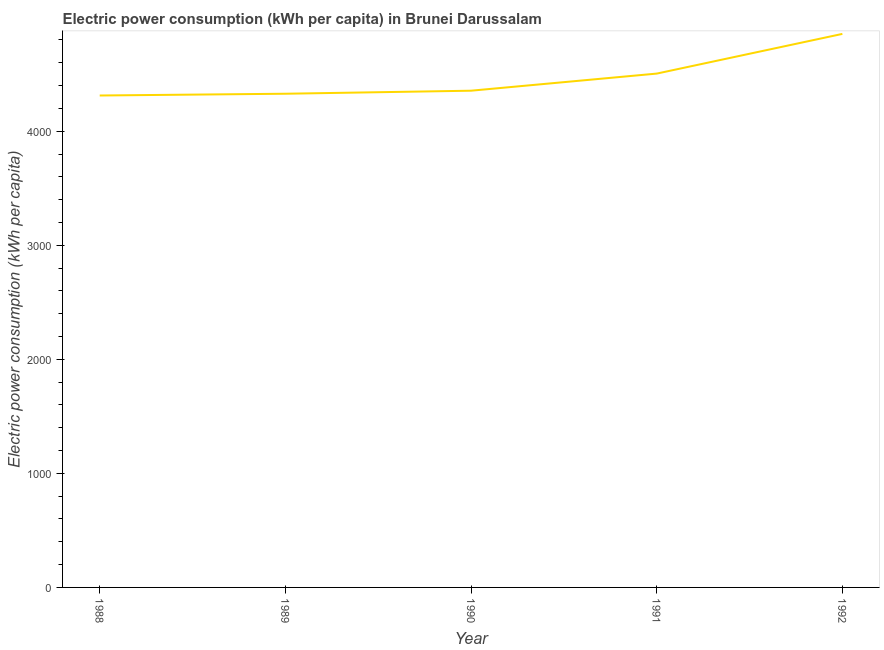What is the electric power consumption in 1992?
Your answer should be very brief. 4853.14. Across all years, what is the maximum electric power consumption?
Your response must be concise. 4853.14. Across all years, what is the minimum electric power consumption?
Make the answer very short. 4313.08. In which year was the electric power consumption maximum?
Provide a succinct answer. 1992. In which year was the electric power consumption minimum?
Provide a succinct answer. 1988. What is the sum of the electric power consumption?
Your answer should be very brief. 2.24e+04. What is the difference between the electric power consumption in 1989 and 1992?
Provide a short and direct response. -524.6. What is the average electric power consumption per year?
Your response must be concise. 4471. What is the median electric power consumption?
Keep it short and to the point. 4355.12. In how many years, is the electric power consumption greater than 3000 kWh per capita?
Make the answer very short. 5. Do a majority of the years between 1992 and 1988 (inclusive) have electric power consumption greater than 3000 kWh per capita?
Your answer should be compact. Yes. What is the ratio of the electric power consumption in 1988 to that in 1991?
Your response must be concise. 0.96. What is the difference between the highest and the second highest electric power consumption?
Ensure brevity in your answer.  348. What is the difference between the highest and the lowest electric power consumption?
Your response must be concise. 540.06. Does the electric power consumption monotonically increase over the years?
Provide a succinct answer. Yes. How many lines are there?
Keep it short and to the point. 1. How many years are there in the graph?
Give a very brief answer. 5. What is the difference between two consecutive major ticks on the Y-axis?
Provide a short and direct response. 1000. Are the values on the major ticks of Y-axis written in scientific E-notation?
Offer a very short reply. No. Does the graph contain any zero values?
Ensure brevity in your answer.  No. What is the title of the graph?
Your answer should be compact. Electric power consumption (kWh per capita) in Brunei Darussalam. What is the label or title of the X-axis?
Keep it short and to the point. Year. What is the label or title of the Y-axis?
Provide a succinct answer. Electric power consumption (kWh per capita). What is the Electric power consumption (kWh per capita) in 1988?
Offer a very short reply. 4313.08. What is the Electric power consumption (kWh per capita) of 1989?
Your answer should be compact. 4328.54. What is the Electric power consumption (kWh per capita) in 1990?
Ensure brevity in your answer.  4355.12. What is the Electric power consumption (kWh per capita) of 1991?
Give a very brief answer. 4505.13. What is the Electric power consumption (kWh per capita) of 1992?
Provide a short and direct response. 4853.14. What is the difference between the Electric power consumption (kWh per capita) in 1988 and 1989?
Ensure brevity in your answer.  -15.46. What is the difference between the Electric power consumption (kWh per capita) in 1988 and 1990?
Ensure brevity in your answer.  -42.04. What is the difference between the Electric power consumption (kWh per capita) in 1988 and 1991?
Make the answer very short. -192.06. What is the difference between the Electric power consumption (kWh per capita) in 1988 and 1992?
Your answer should be very brief. -540.06. What is the difference between the Electric power consumption (kWh per capita) in 1989 and 1990?
Offer a terse response. -26.58. What is the difference between the Electric power consumption (kWh per capita) in 1989 and 1991?
Provide a short and direct response. -176.6. What is the difference between the Electric power consumption (kWh per capita) in 1989 and 1992?
Make the answer very short. -524.6. What is the difference between the Electric power consumption (kWh per capita) in 1990 and 1991?
Make the answer very short. -150.02. What is the difference between the Electric power consumption (kWh per capita) in 1990 and 1992?
Offer a terse response. -498.02. What is the difference between the Electric power consumption (kWh per capita) in 1991 and 1992?
Ensure brevity in your answer.  -348. What is the ratio of the Electric power consumption (kWh per capita) in 1988 to that in 1991?
Keep it short and to the point. 0.96. What is the ratio of the Electric power consumption (kWh per capita) in 1988 to that in 1992?
Provide a short and direct response. 0.89. What is the ratio of the Electric power consumption (kWh per capita) in 1989 to that in 1990?
Provide a short and direct response. 0.99. What is the ratio of the Electric power consumption (kWh per capita) in 1989 to that in 1991?
Your response must be concise. 0.96. What is the ratio of the Electric power consumption (kWh per capita) in 1989 to that in 1992?
Your response must be concise. 0.89. What is the ratio of the Electric power consumption (kWh per capita) in 1990 to that in 1991?
Provide a short and direct response. 0.97. What is the ratio of the Electric power consumption (kWh per capita) in 1990 to that in 1992?
Keep it short and to the point. 0.9. What is the ratio of the Electric power consumption (kWh per capita) in 1991 to that in 1992?
Ensure brevity in your answer.  0.93. 